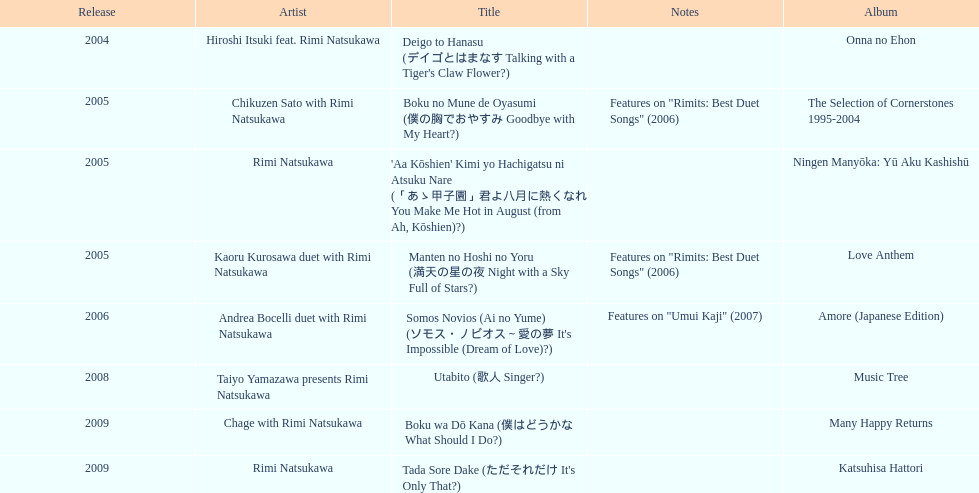What year was the first title released? 2004. 